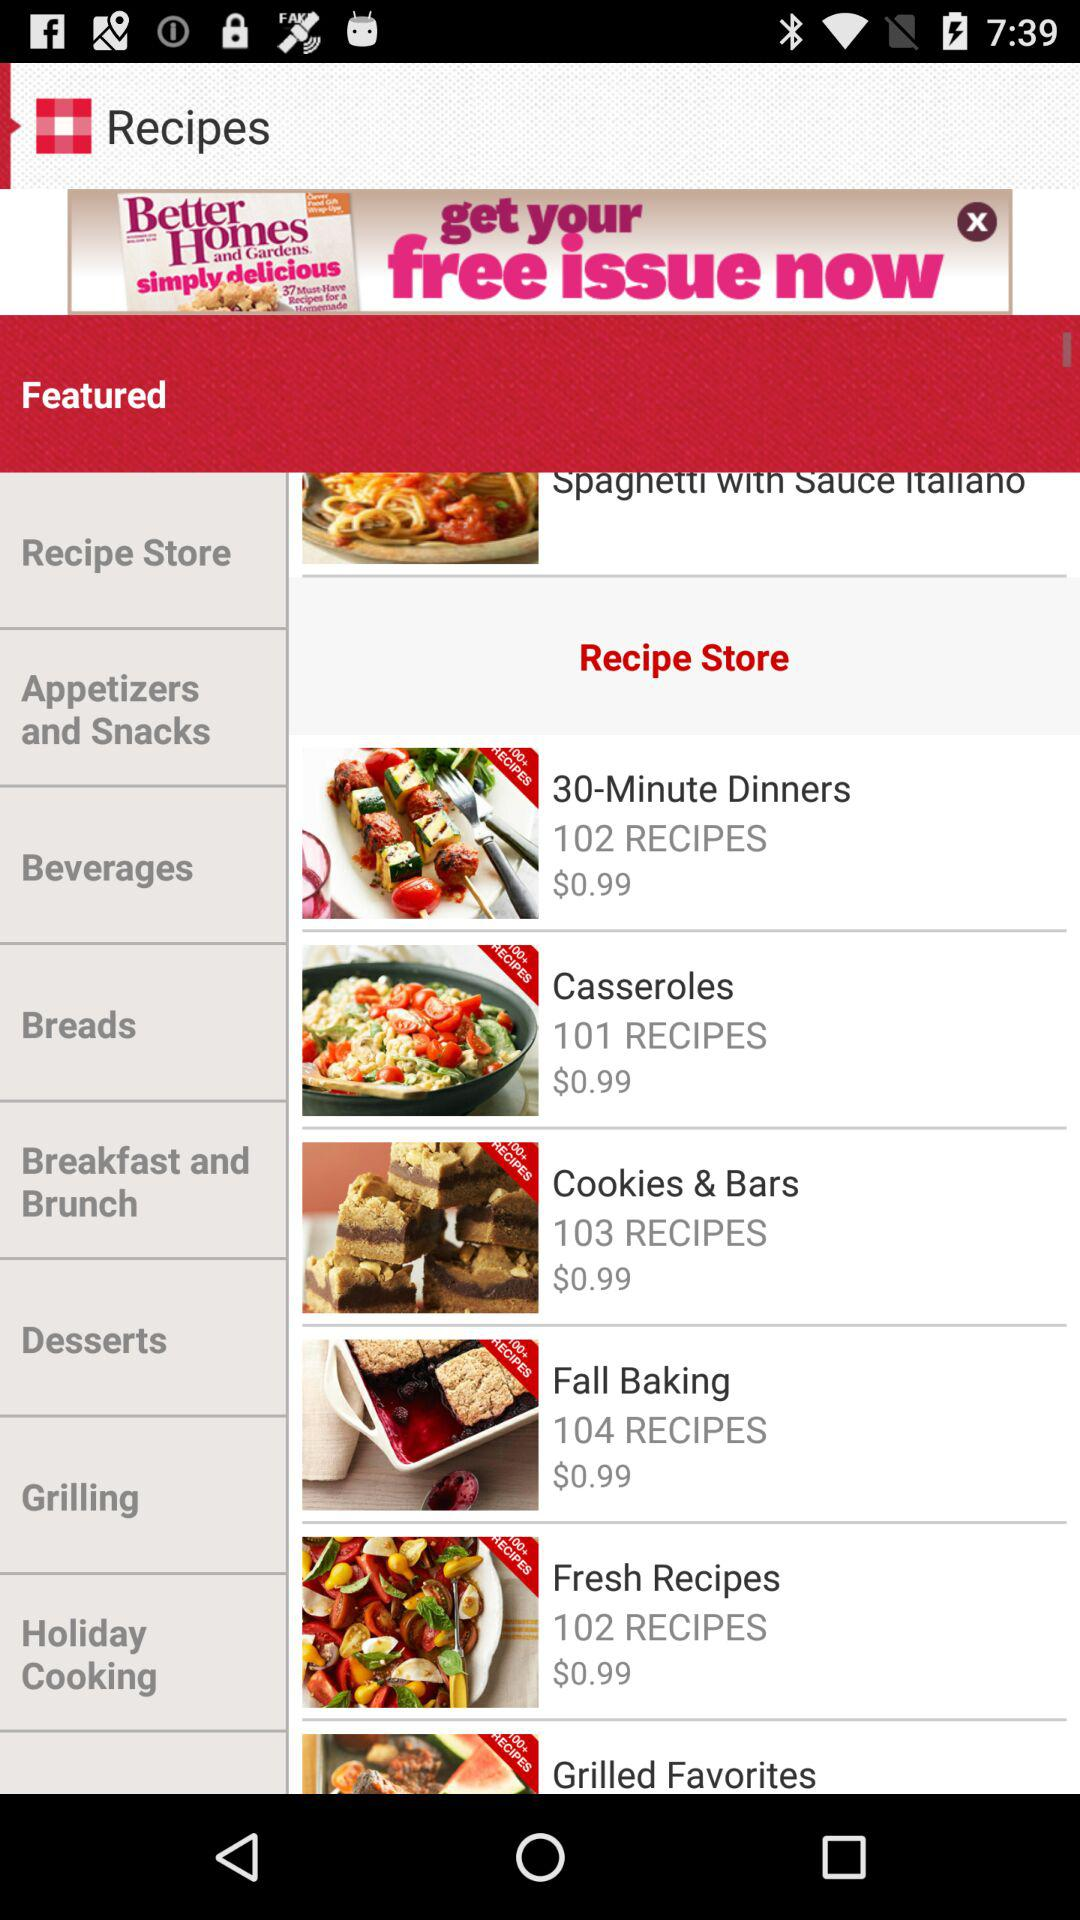What is the price of cookies & bars? The price of cookies & bars is $0.99. 